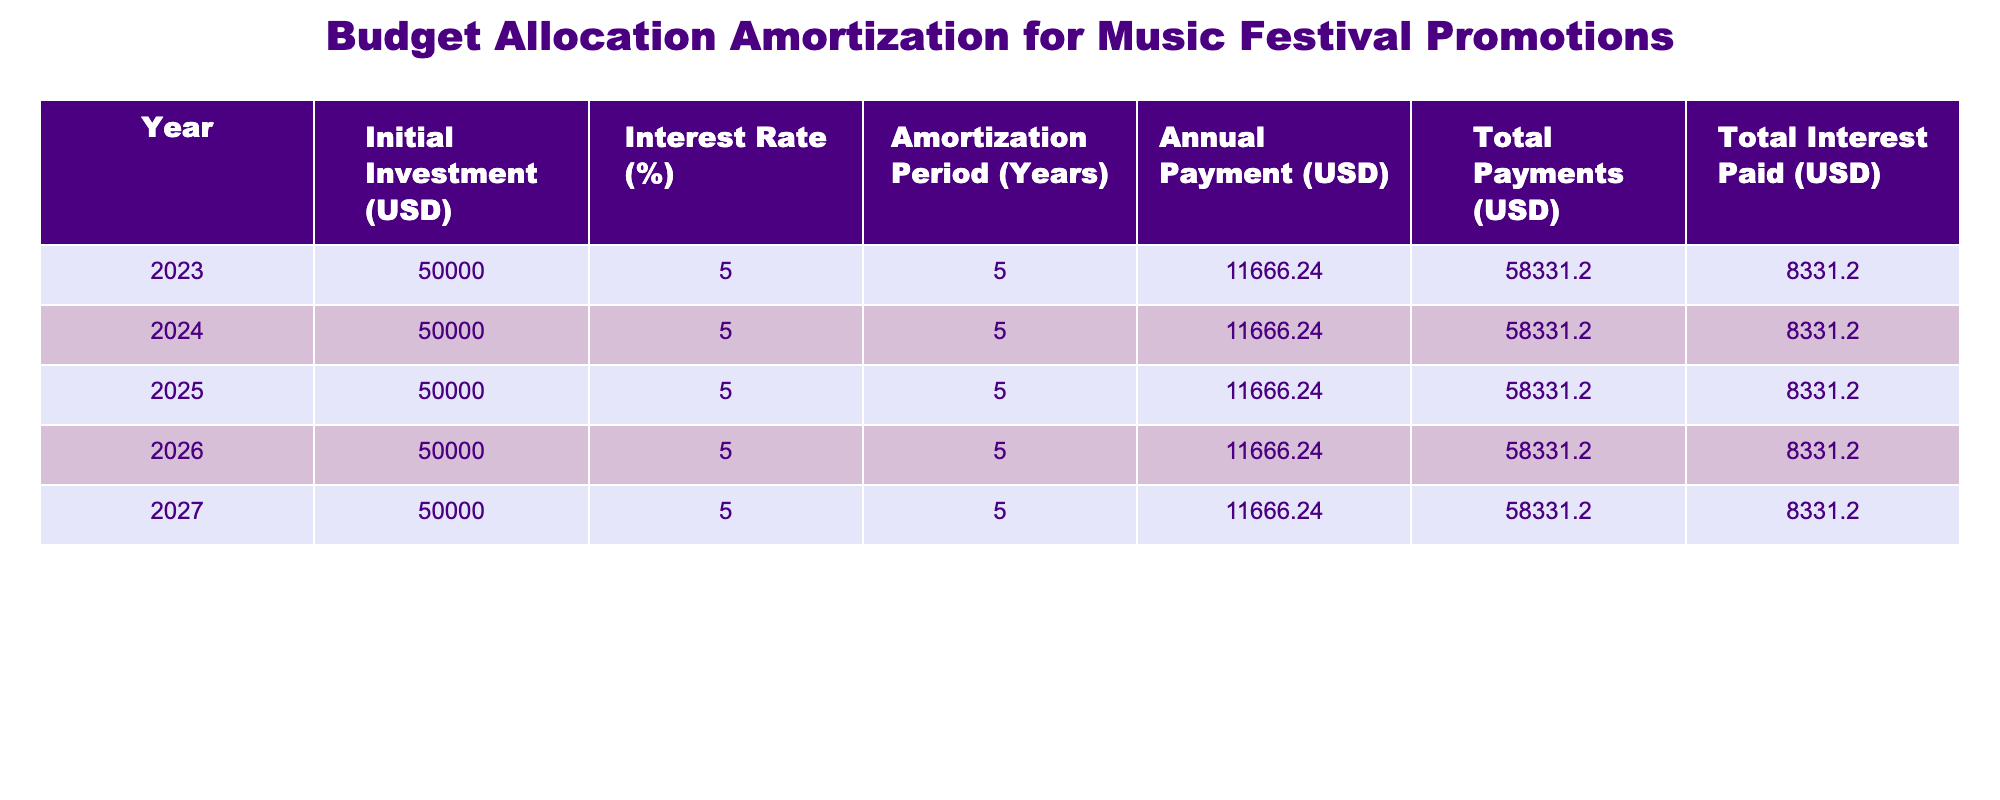What is the total interest paid over the amortization period? The total interest paid is consistently listed for each year, which is 8331.20 USD. Since the amortization period is 5 years, this value remains the same for each year, leading to a total interest paid of 8331.20 USD.
Answer: 8331.20 USD What is the annual payment for each year? The annual payment is mentioned in the "Annual Payment (USD)" column for all years, which is 11666.24 USD. Therefore, the annual payment is the same each year during the amortization period.
Answer: 11666.24 USD True or False: The initial investment increases each year. Referring to the "Initial Investment (USD)" column, it is evident that the initial investment remains constant at 50000 USD for all years. Thus, the statement is false.
Answer: False What is the total amount paid by the end of the amortization period? The total payments column indicates that the total amount paid after five years is 58331.20 USD. This value is direct from the table, calculated as 11666.24 USD multiplied by 5 years.
Answer: 58331.20 USD What is the average annual payment over the 5 years? The annual payment is 11666.24 USD each year, and there are 5 years. To find the average, simply use that one consistent value, which gives 11666.24 USD as both the yearly payment and the average.
Answer: 11666.24 USD What is the ratio of total interest paid to the total payments? To calculate the ratio, we take the total interest paid (8331.20 USD) and the total payments (58331.20 USD). The ratio is calculated as 8331.20 divided by 58331.20, which simplifies down to approximately 0.1425 when you divide the numbers.
Answer: 0.1425 How does the total payment compare to the initial investment? The total payment of 58331.20 USD is higher than the initial investment of 50000 USD. To compare, subtract the initial investment from the total payment: 58331.20 - 50000 = 831.20, indicating a significant return in costs.
Answer: Higher What would be the total interest paid if the interest rate increased to 6%? The total interest paid would change if the interest rate impacted the annual payment amount. While the question requires financial calculations beyond the provided table, it can be reasoned that with an increase to 6%, the total interest would be greater than 8331.20 USD, indicating more expense.
Answer: Higher than 8331.20 USD 